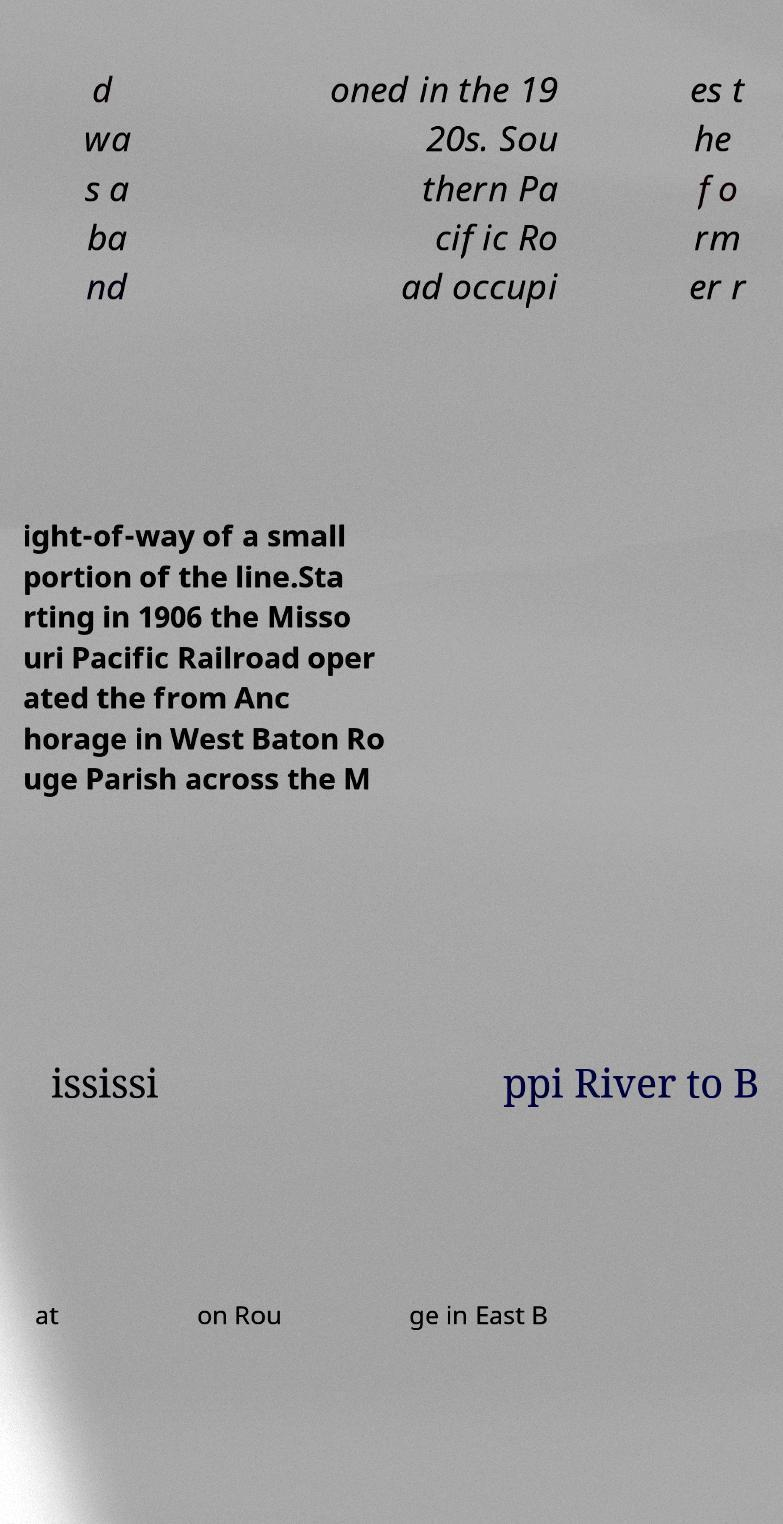Could you assist in decoding the text presented in this image and type it out clearly? d wa s a ba nd oned in the 19 20s. Sou thern Pa cific Ro ad occupi es t he fo rm er r ight-of-way of a small portion of the line.Sta rting in 1906 the Misso uri Pacific Railroad oper ated the from Anc horage in West Baton Ro uge Parish across the M ississi ppi River to B at on Rou ge in East B 